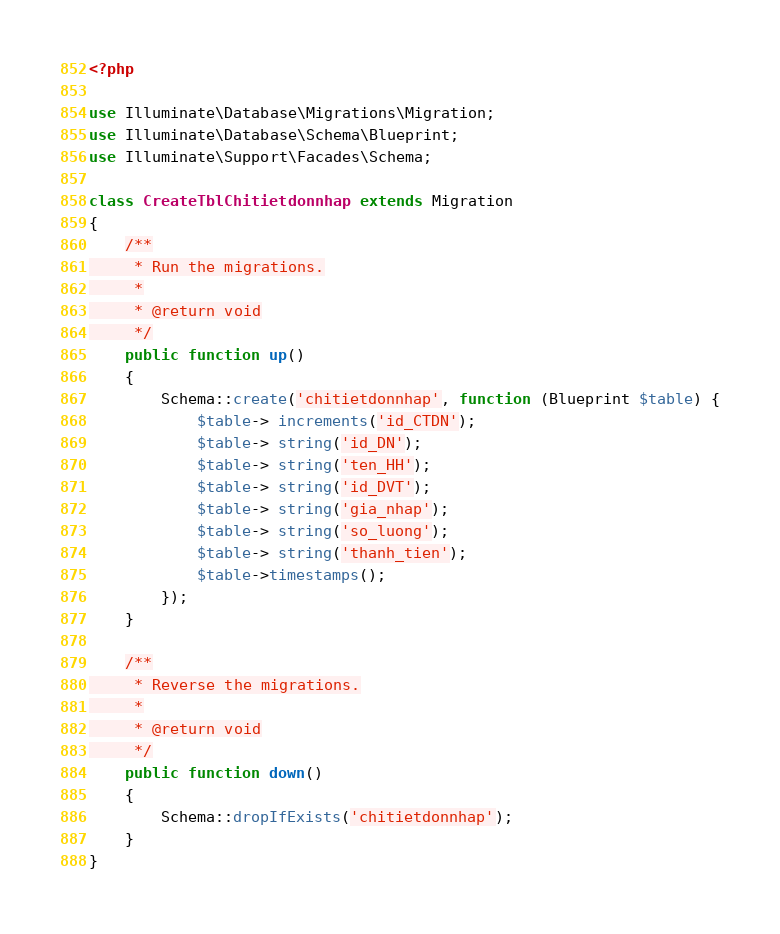<code> <loc_0><loc_0><loc_500><loc_500><_PHP_><?php

use Illuminate\Database\Migrations\Migration;
use Illuminate\Database\Schema\Blueprint;
use Illuminate\Support\Facades\Schema;

class CreateTblChitietdonnhap extends Migration
{
    /**
     * Run the migrations.
     *
     * @return void
     */
    public function up()
    {
        Schema::create('chitietdonnhap', function (Blueprint $table) {
            $table-> increments('id_CTDN');
            $table-> string('id_DN');
            $table-> string('ten_HH');
            $table-> string('id_DVT');
            $table-> string('gia_nhap');
            $table-> string('so_luong');
            $table-> string('thanh_tien');
            $table->timestamps();
        });
    }

    /**
     * Reverse the migrations.
     *
     * @return void
     */
    public function down()
    {
        Schema::dropIfExists('chitietdonnhap');
    }
}
</code> 